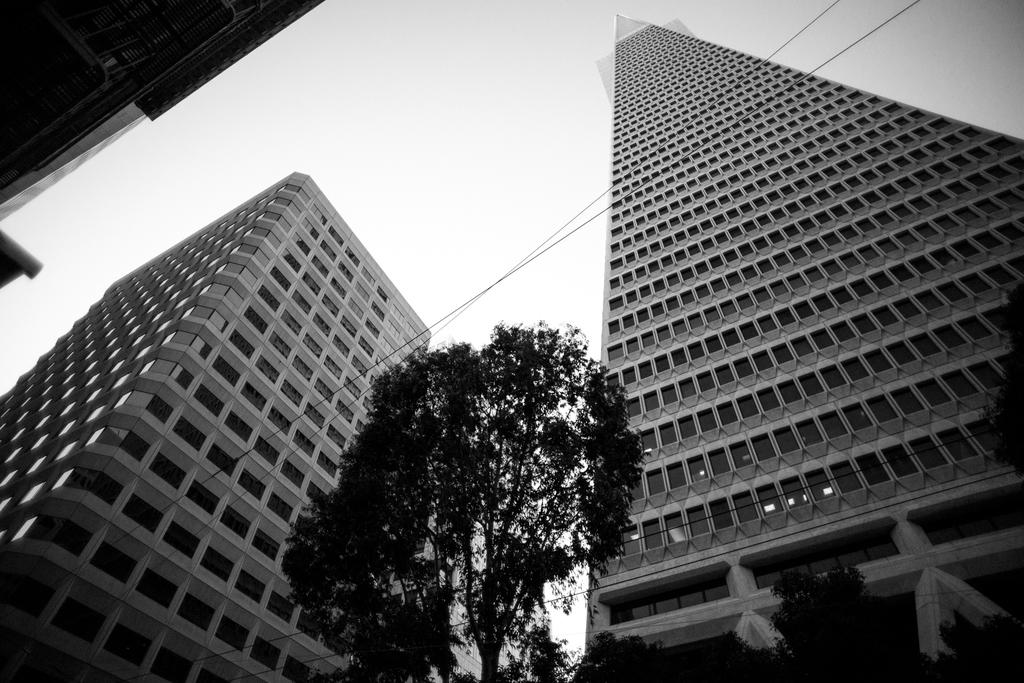What type of natural element is present in the image? There is a tree in the image. What man-made structures can be seen in the image? There are two buildings in the image. What can be seen in the background of the image? The sky is visible in the background of the image. What is the color of the sky in the image? The sky is described as white in color. How does the uncle feel during the afternoon in the image? There is no uncle or indication of time of day (afternoon) present in the image. 